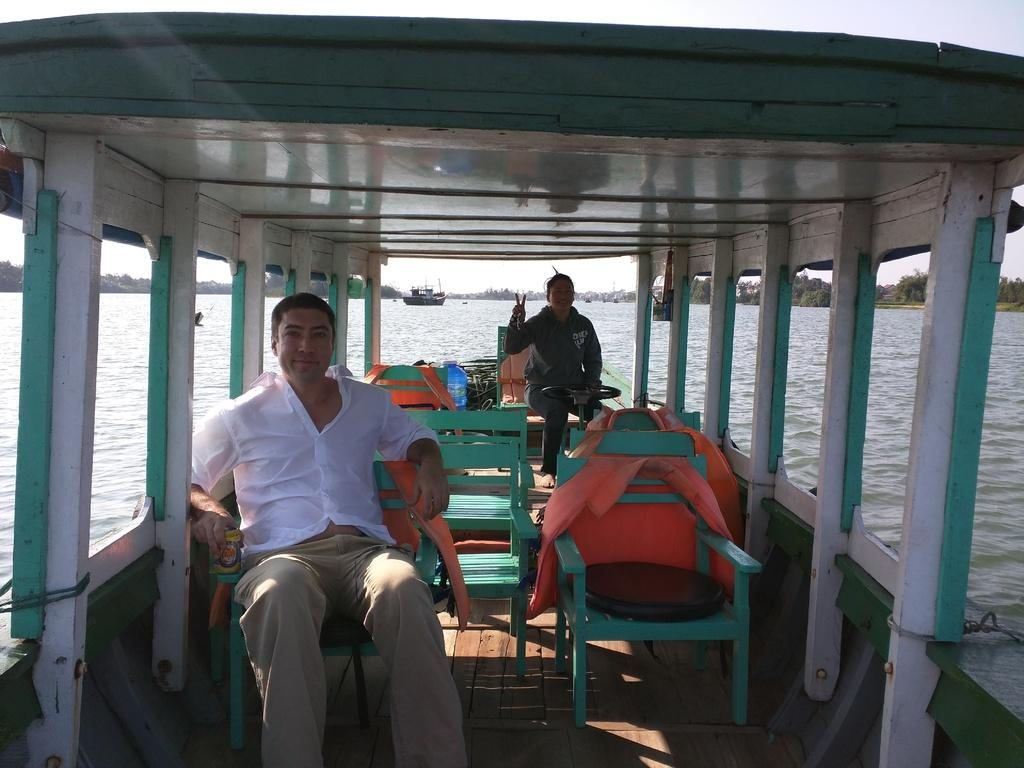Who can be seen in the image? There is a man and a woman in the image. What are they doing in the image? They are riding in a boat. Where is the boat located? The boat is on water. What can be seen in the background of the image? There are trees, a ship, and the sky visible in the background of the image. What type of bomb can be seen in the image? There is no bomb present in the image. How does the shade affect the people in the boat? There is no mention of shade in the image, so it cannot be determined how it would affect the people in the boat. 